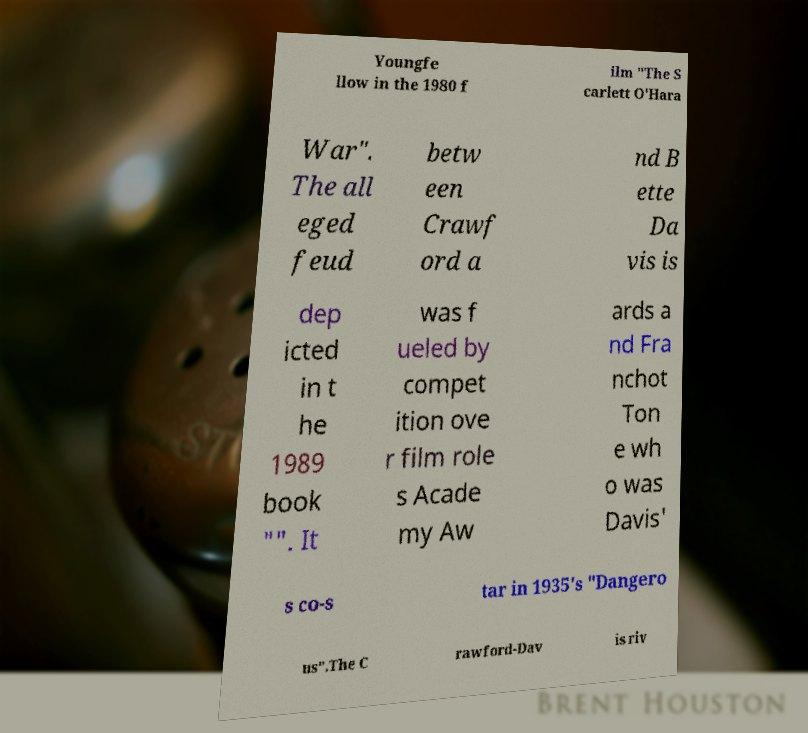Please read and relay the text visible in this image. What does it say? Youngfe llow in the 1980 f ilm "The S carlett O'Hara War". The all eged feud betw een Crawf ord a nd B ette Da vis is dep icted in t he 1989 book "". It was f ueled by compet ition ove r film role s Acade my Aw ards a nd Fra nchot Ton e wh o was Davis' s co-s tar in 1935's "Dangero us".The C rawford-Dav is riv 